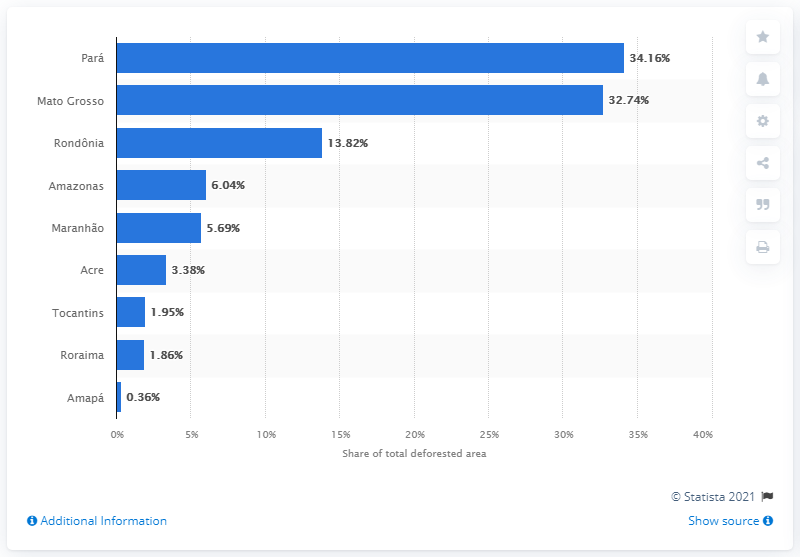Outline some significant characteristics in this image. Mato Grosso was the second state with the highest percentage of deforestation in the country. 